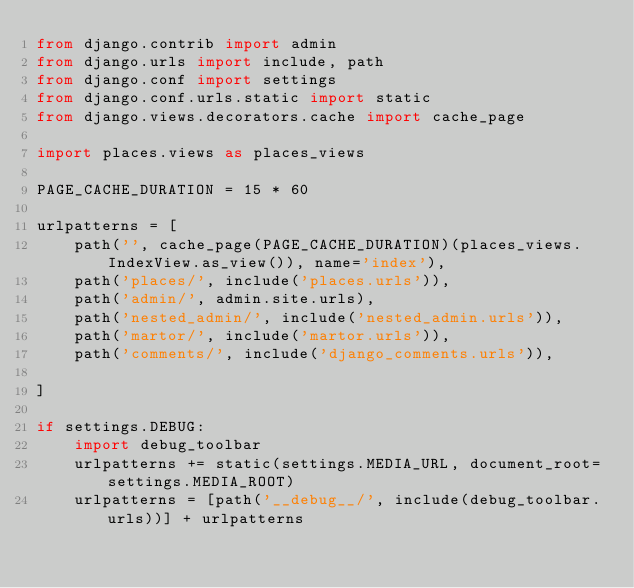Convert code to text. <code><loc_0><loc_0><loc_500><loc_500><_Python_>from django.contrib import admin
from django.urls import include, path
from django.conf import settings
from django.conf.urls.static import static
from django.views.decorators.cache import cache_page

import places.views as places_views

PAGE_CACHE_DURATION = 15 * 60

urlpatterns = [
    path('', cache_page(PAGE_CACHE_DURATION)(places_views.IndexView.as_view()), name='index'),
    path('places/', include('places.urls')),
    path('admin/', admin.site.urls),
    path('nested_admin/', include('nested_admin.urls')),
    path('martor/', include('martor.urls')),
    path('comments/', include('django_comments.urls')),

]

if settings.DEBUG:
    import debug_toolbar
    urlpatterns += static(settings.MEDIA_URL, document_root=settings.MEDIA_ROOT)
    urlpatterns = [path('__debug__/', include(debug_toolbar.urls))] + urlpatterns
</code> 